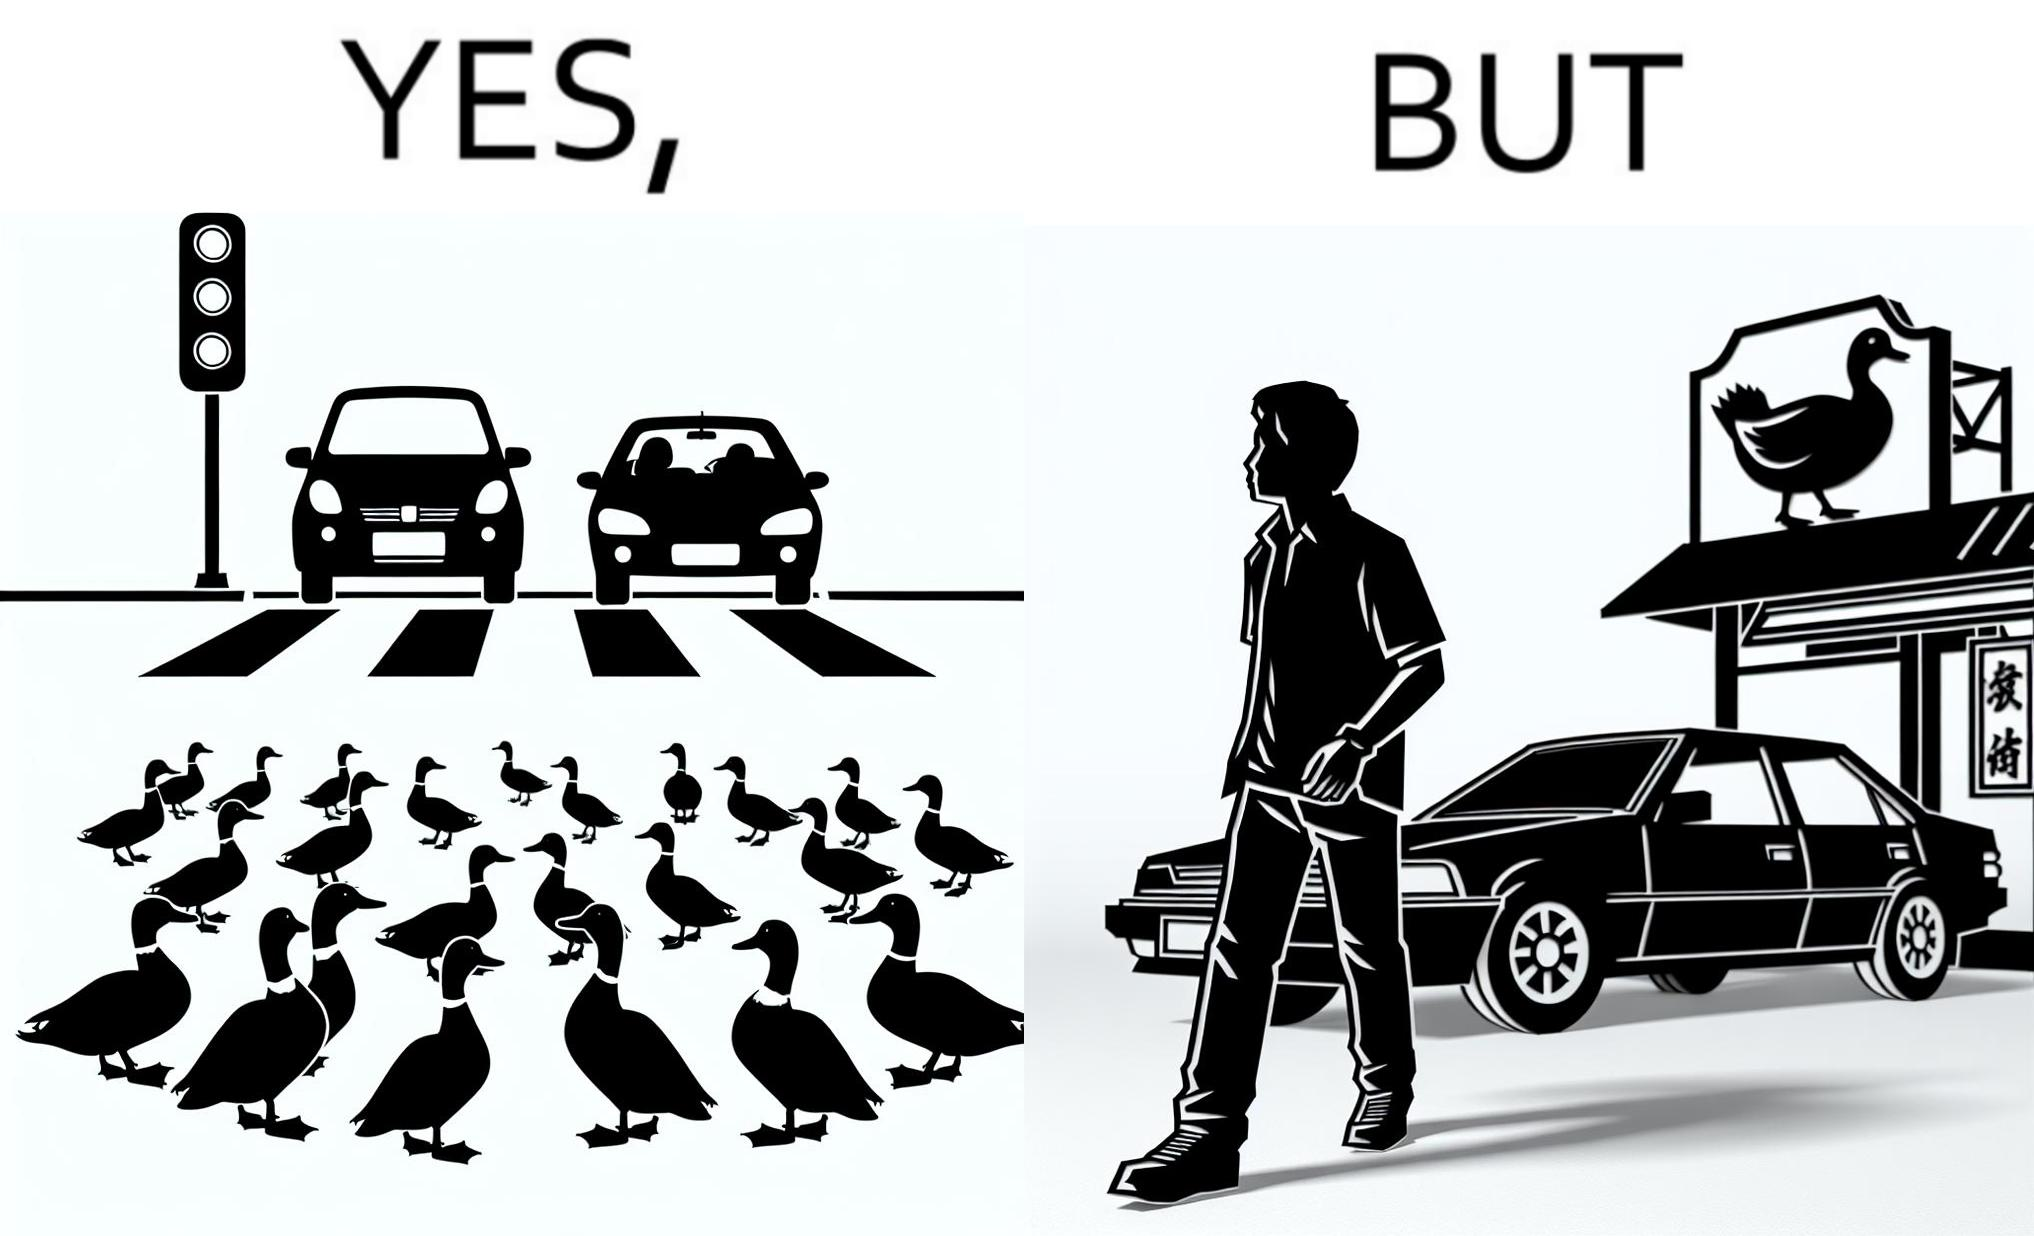Would you classify this image as satirical? Yes, this image is satirical. 